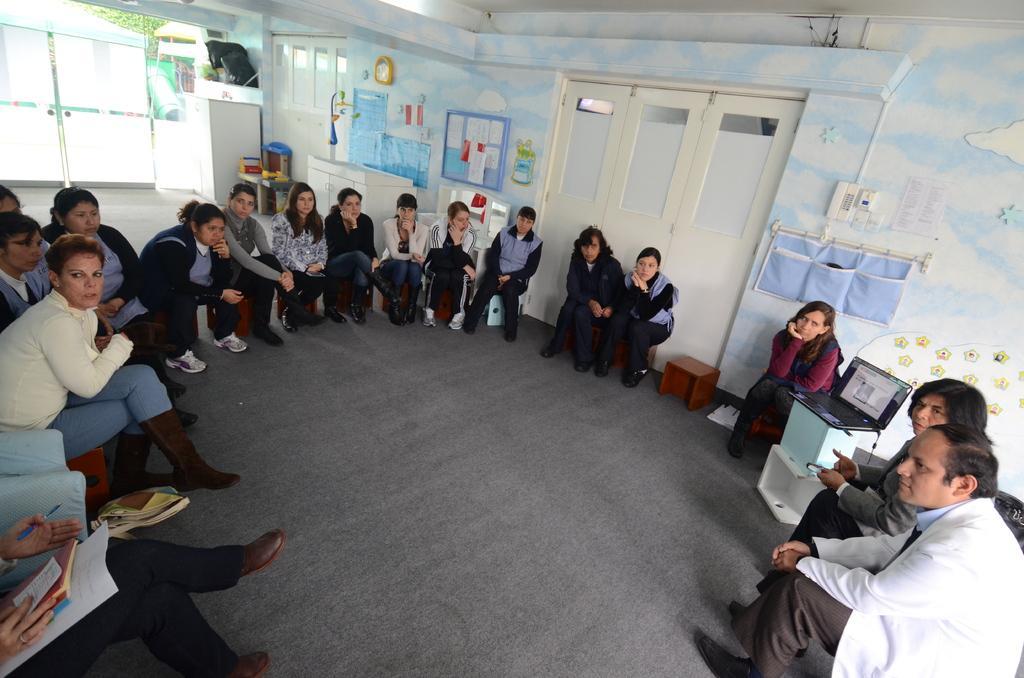Can you describe this image briefly? In this image there are people sitting on chairs, in the background there are walls to that walls there are doors, posters and clothes. 